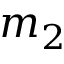<formula> <loc_0><loc_0><loc_500><loc_500>m _ { 2 }</formula> 